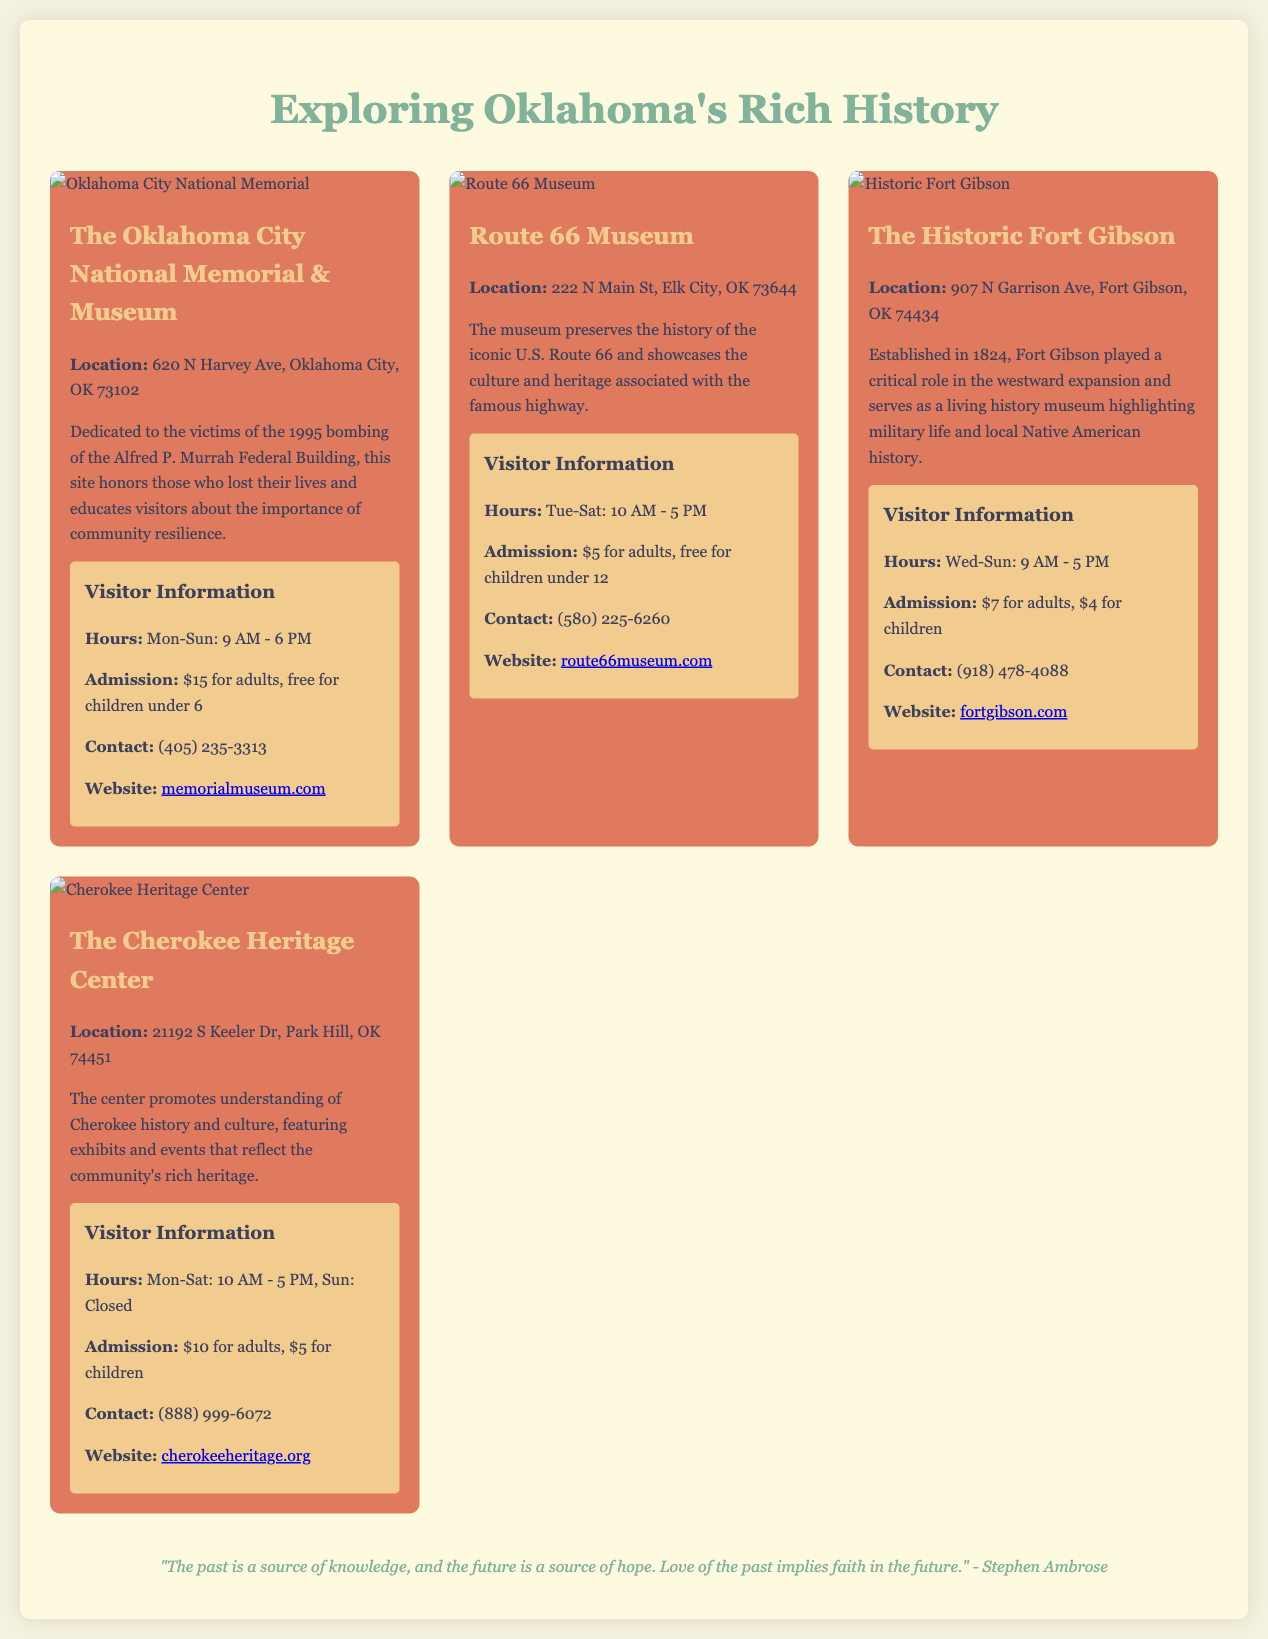What is the location of the Oklahoma City National Memorial? The document specifies the address of the memorial as "620 N Harvey Ave, Oklahoma City, OK 73102."
Answer: 620 N Harvey Ave, Oklahoma City, OK 73102 What is the admission fee for adults at the Route 66 Museum? The museum's admission for adults is listed as "$5."
Answer: $5 How many days a week is the Cherokee Heritage Center open? The document states that the center is open "Mon-Sat," totaling six days a week.
Answer: 6 days What type of history does the Historic Fort Gibson highlight? The Fort Gibson site specifically highlights "military life and local Native American history."
Answer: Military life and local Native American history Which historical site focuses on the victims of a bombing? The Oklahoma City National Memorial focuses on the victims of the bombing of the Alfred P. Murrah Federal Building.
Answer: Oklahoma City National Memorial What is the total admission fee for an adult and a child at the Cherokee Heritage Center? The adult fee is "$10" and the child fee is "$5," making the total admission "$15."
Answer: $15 